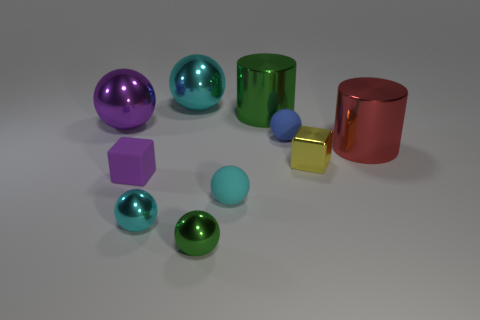Are there fewer big metallic objects in front of the tiny purple matte thing than small green shiny objects?
Your answer should be very brief. Yes. Are the small sphere behind the cyan rubber sphere and the large cyan ball made of the same material?
Ensure brevity in your answer.  No. The green thing behind the small rubber sphere that is behind the tiny rubber block that is left of the green shiny cylinder is what shape?
Your answer should be very brief. Cylinder. Is there a yellow metal block of the same size as the red thing?
Ensure brevity in your answer.  No. The red cylinder has what size?
Offer a very short reply. Large. How many shiny balls have the same size as the rubber block?
Ensure brevity in your answer.  2. Is the number of red metal objects behind the green cylinder less than the number of large cyan balls in front of the yellow metal object?
Provide a succinct answer. No. There is a ball that is in front of the tiny cyan ball that is left of the cyan metal sphere behind the small cyan matte thing; what size is it?
Provide a short and direct response. Small. How big is the shiny object that is both behind the purple cube and in front of the red object?
Ensure brevity in your answer.  Small. There is a green metallic thing behind the block that is on the left side of the big green shiny cylinder; what is its shape?
Your answer should be compact. Cylinder. 